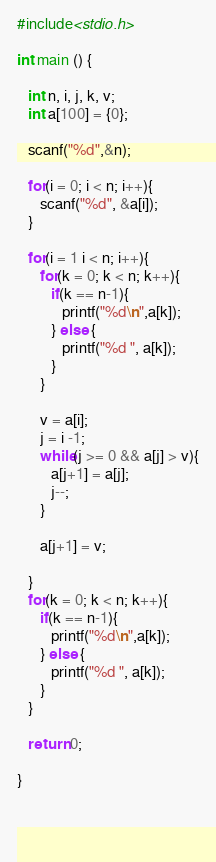<code> <loc_0><loc_0><loc_500><loc_500><_C_>#include<stdio.h>

int main () {

   int n, i, j, k, v;
   int a[100] = {0};

   scanf("%d",&n);

   for(i = 0; i < n; i++){
      scanf("%d", &a[i]);
   }

   for(i = 1 i < n; i++){
      for(k = 0; k < n; k++){
         if(k == n-1){
            printf("%d\n",a[k]);
         } else {
            printf("%d ", a[k]);
         }
      }

      v = a[i];
      j = i -1;
      while(j >= 0 && a[j] > v){
         a[j+1] = a[j];
         j--;
      }

      a[j+1] = v;

   }
   for(k = 0; k < n; k++){
      if(k == n-1){
         printf("%d\n",a[k]);
      } else {
         printf("%d ", a[k]);
      }
   }

   return 0;

}


   </code> 